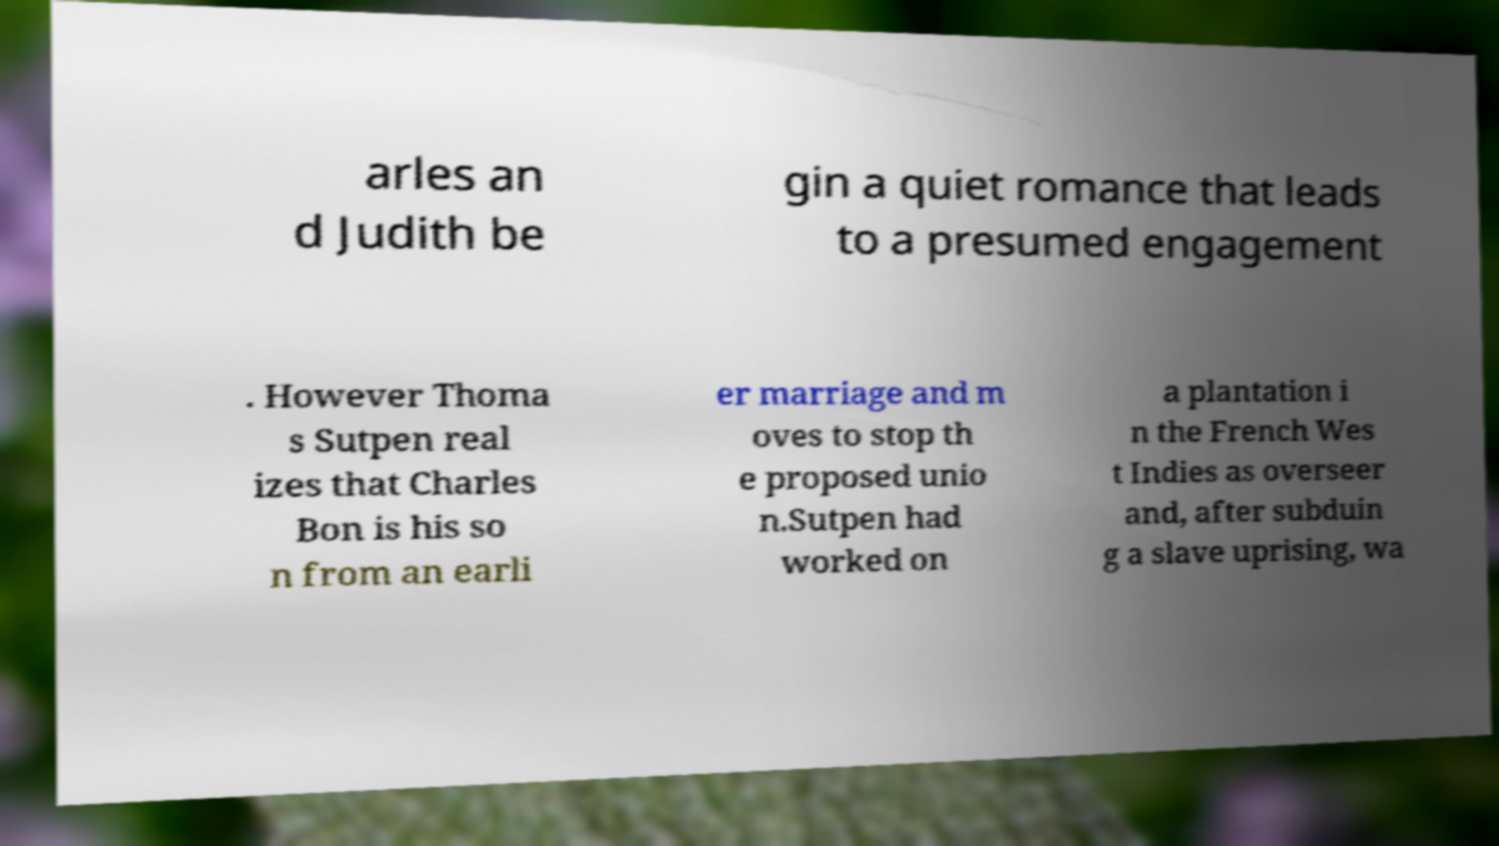Can you read and provide the text displayed in the image?This photo seems to have some interesting text. Can you extract and type it out for me? arles an d Judith be gin a quiet romance that leads to a presumed engagement . However Thoma s Sutpen real izes that Charles Bon is his so n from an earli er marriage and m oves to stop th e proposed unio n.Sutpen had worked on a plantation i n the French Wes t Indies as overseer and, after subduin g a slave uprising, wa 